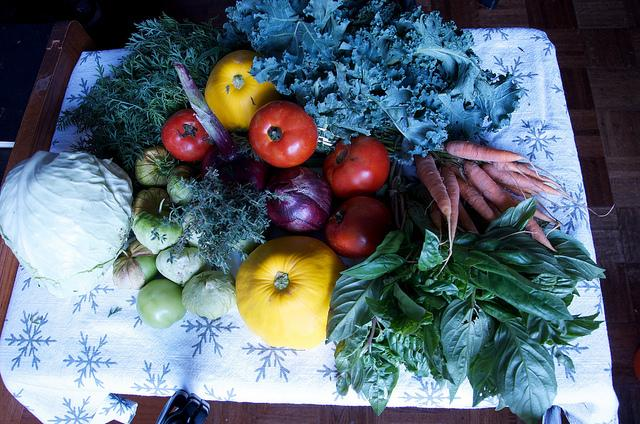What is the large vegetable on the far left? Please explain your reasoning. cabbage. The big vegetable is a cabbage because it is green and has leaves like a cabbage does 